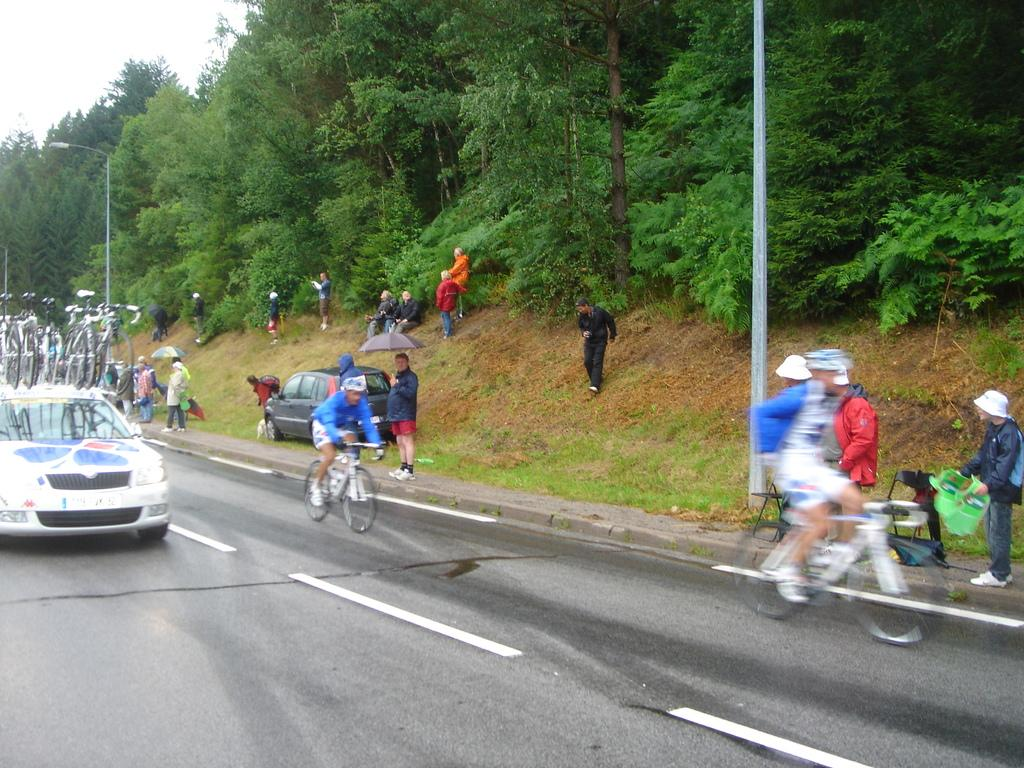What are the people in the image doing? There are persons standing and sitting in the image, and two persons are riding bicycles. Are the bicycle riders taking any safety precautions? Yes, the bicycle riders are wearing helmets. What else can be seen in the image besides people? There is a car visible on the road, trees are present, and the sky is visible. Where is the mailbox located in the image? There is no mailbox present in the image. What type of lunchroom can be seen in the image? There is no lunchroom present in the image. 